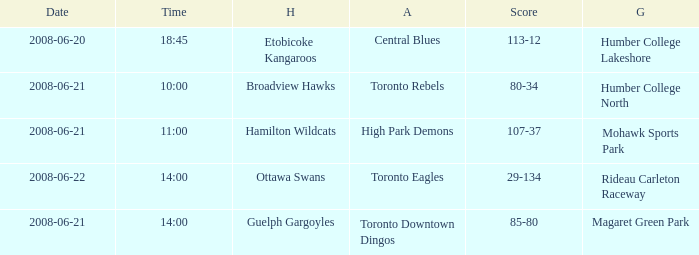What is the Time with a Score that is 80-34? 10:00. 